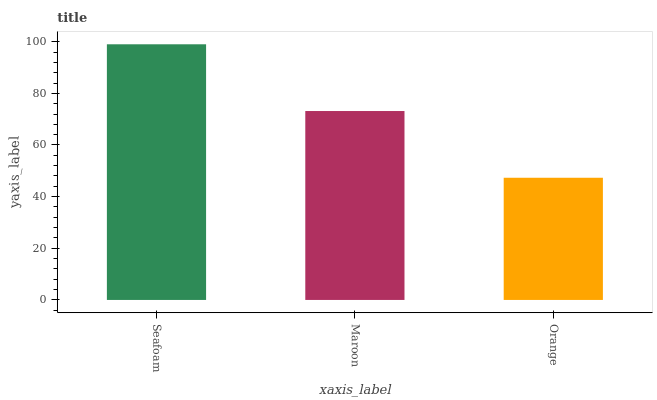Is Orange the minimum?
Answer yes or no. Yes. Is Seafoam the maximum?
Answer yes or no. Yes. Is Maroon the minimum?
Answer yes or no. No. Is Maroon the maximum?
Answer yes or no. No. Is Seafoam greater than Maroon?
Answer yes or no. Yes. Is Maroon less than Seafoam?
Answer yes or no. Yes. Is Maroon greater than Seafoam?
Answer yes or no. No. Is Seafoam less than Maroon?
Answer yes or no. No. Is Maroon the high median?
Answer yes or no. Yes. Is Maroon the low median?
Answer yes or no. Yes. Is Seafoam the high median?
Answer yes or no. No. Is Seafoam the low median?
Answer yes or no. No. 